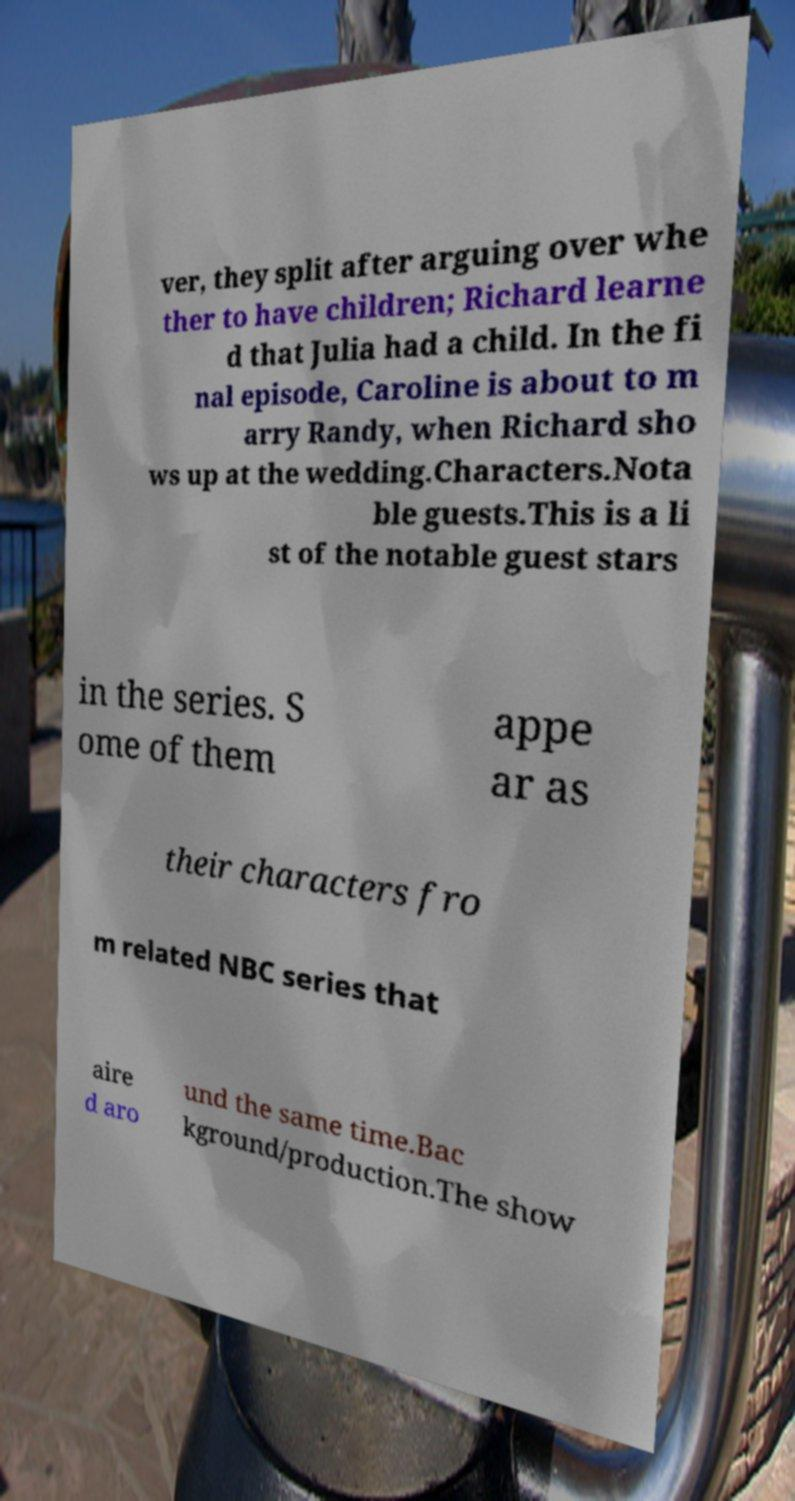Can you read and provide the text displayed in the image?This photo seems to have some interesting text. Can you extract and type it out for me? ver, they split after arguing over whe ther to have children; Richard learne d that Julia had a child. In the fi nal episode, Caroline is about to m arry Randy, when Richard sho ws up at the wedding.Characters.Nota ble guests.This is a li st of the notable guest stars in the series. S ome of them appe ar as their characters fro m related NBC series that aire d aro und the same time.Bac kground/production.The show 